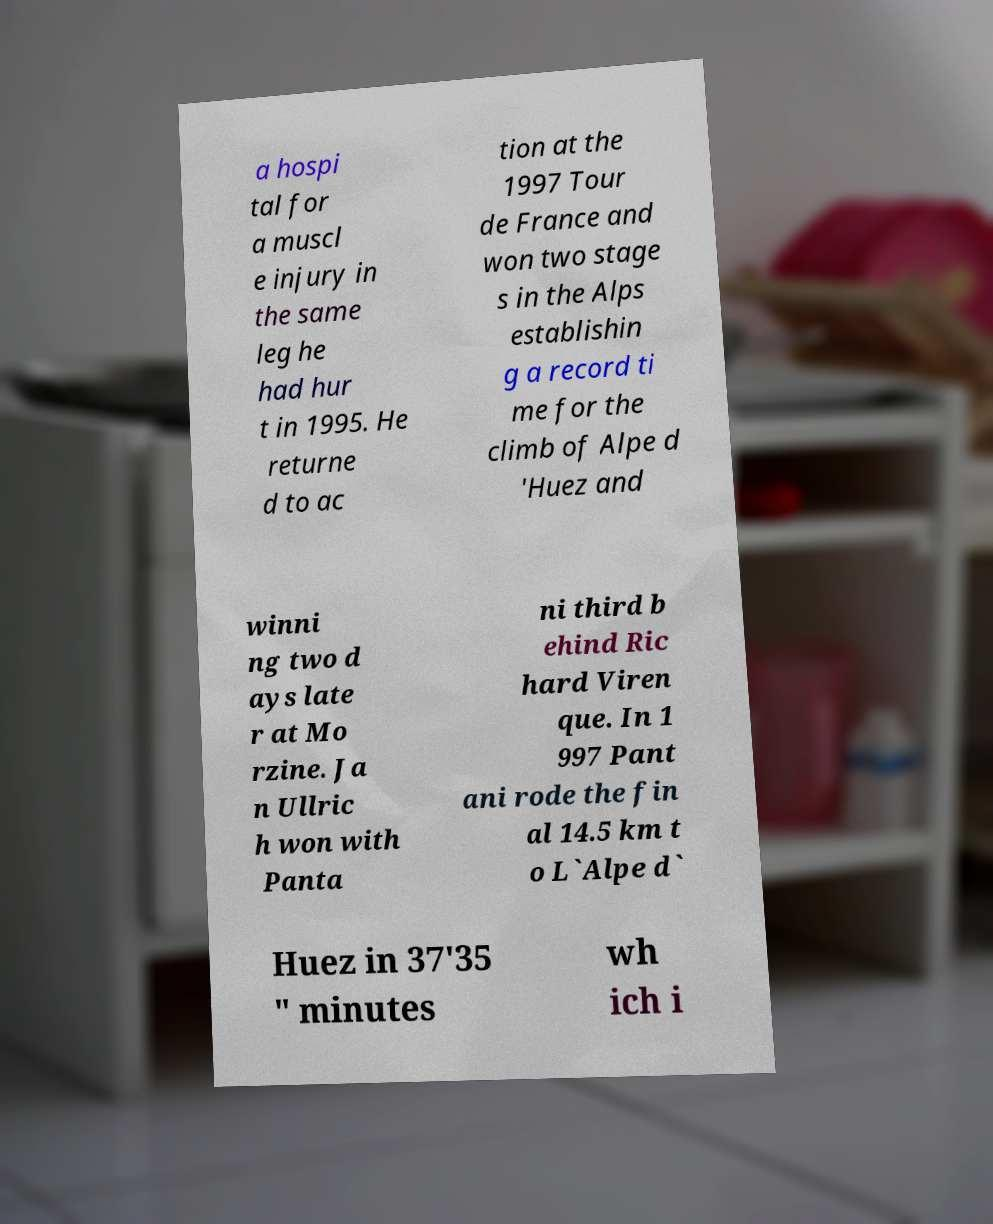What messages or text are displayed in this image? I need them in a readable, typed format. a hospi tal for a muscl e injury in the same leg he had hur t in 1995. He returne d to ac tion at the 1997 Tour de France and won two stage s in the Alps establishin g a record ti me for the climb of Alpe d 'Huez and winni ng two d ays late r at Mo rzine. Ja n Ullric h won with Panta ni third b ehind Ric hard Viren que. In 1 997 Pant ani rode the fin al 14.5 km t o L`Alpe d` Huez in 37'35 " minutes wh ich i 